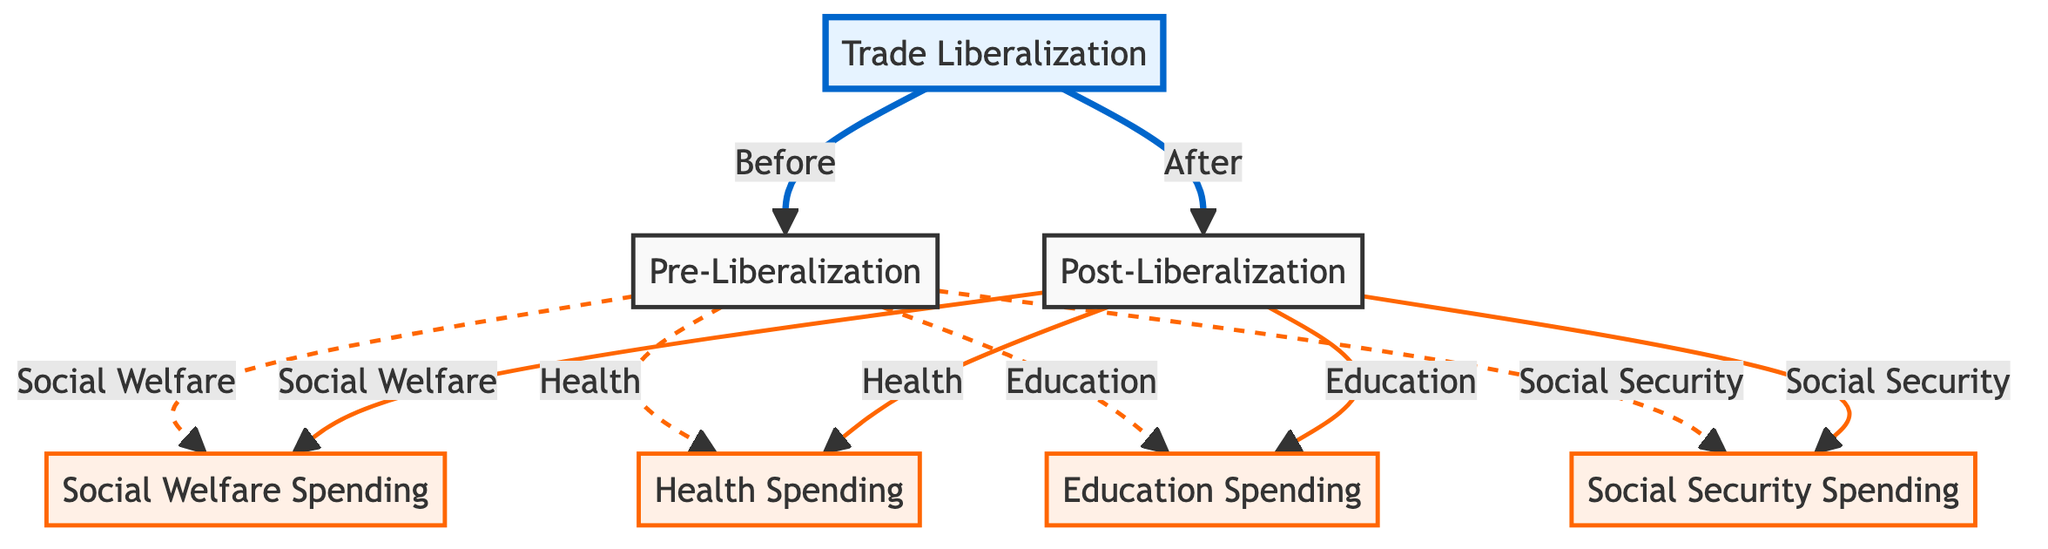What is the main event that separates the two timelines in the diagram? The main event depicted in the diagram is Trade Liberalization, which serves as the dividing point between the pre-liberalization and post-liberalization timelines.
Answer: Trade Liberalization How many main areas of social welfare spending are highlighted in the diagram? The diagram highlights three main areas of social welfare spending: Health, Education, and Social Security.
Answer: Three What type of spending does the node labeled "SW" refer to? The node "SW" represents Social Welfare Spending, which is a collective term for the various expenditures on health, education, and social security.
Answer: Social Welfare Spending Which area of spending is linked to both pre- and post-liberalization periods? Health Spending is connected to both the pre-liberalization and post-liberalization periods, showing that it is analyzed for changes before and after Trade Liberalization.
Answer: Health Spending How does the line style indicate the different timelines in the diagram? The line style for the connections before Trade Liberalization is a dashed line, while the lines after Trade Liberalization are solid, indicating a change in the status of the spending categories.
Answer: Dashed and solid lines What color represents spending in the diagram? The spending nodes in the diagram are represented with a light orange color, which visually differentiates them from the trade liberalization event.
Answer: Light orange Are education expenditures indicated as increasing or decreasing after Trade Liberalization in the diagram? The diagram does not explicitly indicate the trend (increasing or decreasing) of education expenditures post-liberalization, as it focuses on the relationship rather than the specific values.
Answer: Not specified Which expenditure category remains consistent in labeling between pre- and post-liberalization periods? All expenditure categories (Health, Education, Social Security) maintain consistent labeling between the pre- and post-liberalization periods, noted by their respective links to "SW".
Answer: All categories consistent What does the dashed line style represent in the diagram? The dashed lines in the diagram represent the connections established before the trade liberalization occurs, illustrating the setup of social welfare spending prior to the event.
Answer: Connections before liberalization 